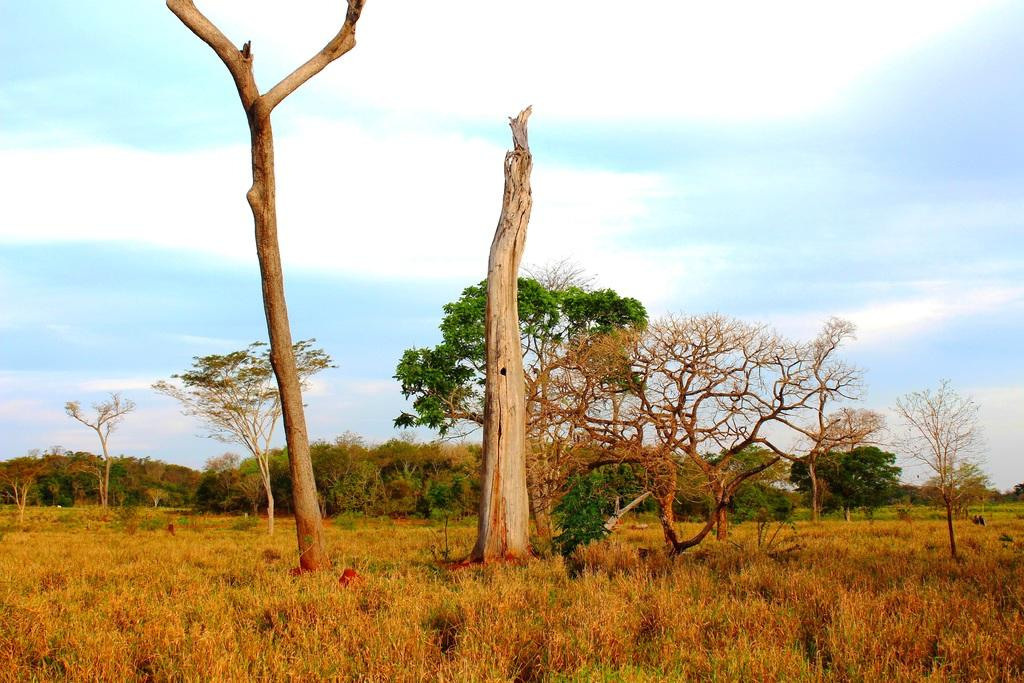What type of vegetation is present in the image? There are trees with branches and leaves in the image. What part of the trees can be seen in the image? Tree trunks are visible in the image. What type of ground cover is present in the image? There is dried grass in the image. What is visible in the background of the image? The sky is visible in the image. Can you see an airplane flying in the sky in the image? No, there is no airplane visible in the sky in the image. 